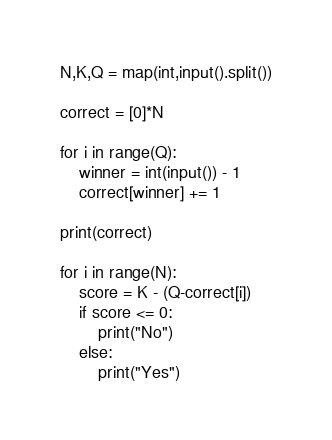Convert code to text. <code><loc_0><loc_0><loc_500><loc_500><_Python_>N,K,Q = map(int,input().split())

correct = [0]*N

for i in range(Q):
    winner = int(input()) - 1
    correct[winner] += 1

print(correct)

for i in range(N):
    score = K - (Q-correct[i])
    if score <= 0:
        print("No")
    else:
        print("Yes")</code> 